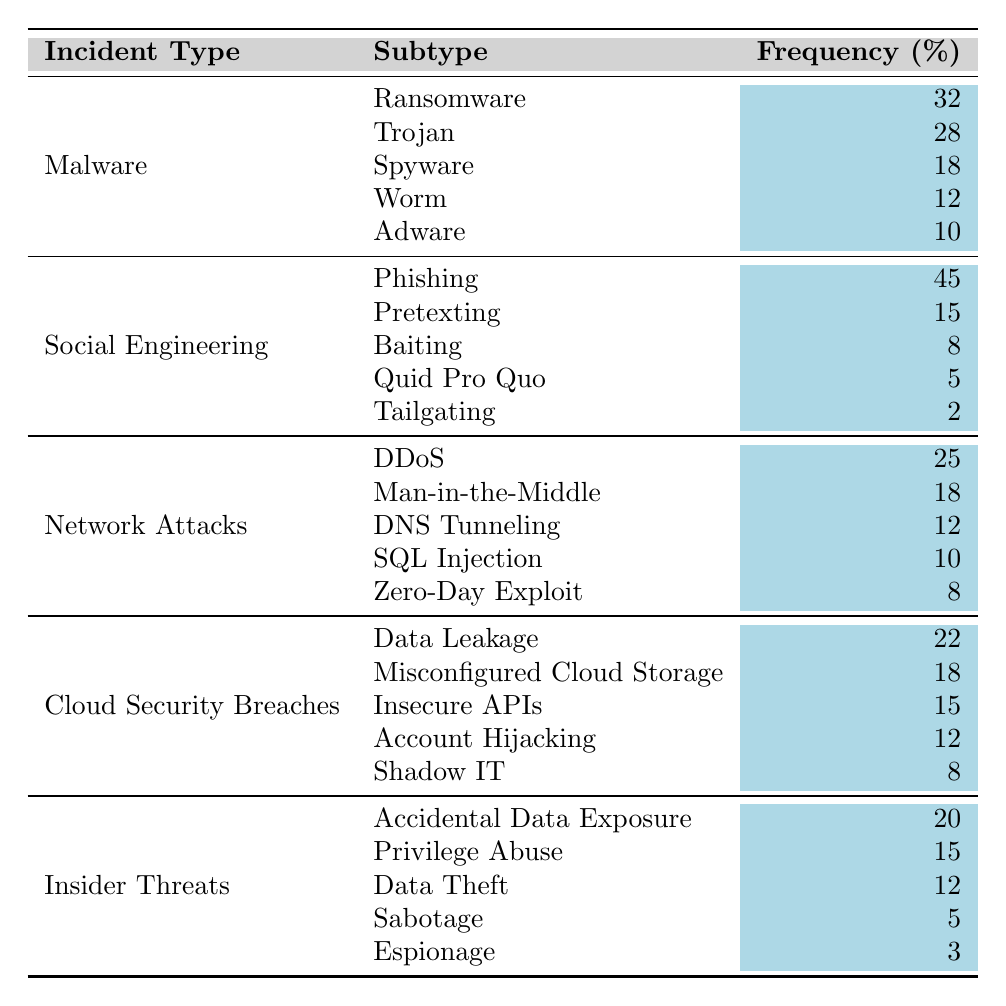What is the total frequency of Malware incidents? The table lists five types of Malware incidents: Ransomware (32), Trojan (28), Spyware (18), Worm (12), and Adware (10). To find the total frequency, we sum these values: 32 + 28 + 18 + 12 + 10 = 100.
Answer: 100 Which social engineering tactic has the highest frequency? Looking at the Social Engineering section, Phishing has the highest frequency with 45 incidents.
Answer: Phishing How many times greater is the frequency of Ransomware compared to Adware? The frequency of Ransomware is 32, and the frequency of Adware is 10. To find how many times greater Ransomware is than Adware, we divide: 32 / 10 = 3.2.
Answer: 3.2 What is the frequency of Data Leakage incidents? The table indicates that Data Leakage, a type of Cloud Security Breach, has a frequency of 22.
Answer: 22 Is the frequency of Insider Threats higher than Network Attacks? The frequency of Insider Threats (20) is lower than the frequency of Network Attacks (sum of values is 73). Therefore, the statement is false.
Answer: No What percentage of Cybersecurity incidents in 2022 were related to Malware? To find the percentage of incidents related to Malware, first calculate the total incidents across all categories: 100 (Malware) + 45 (Social Engineering) + 73 (Network Attacks) + 75 (Cloud Security Breaches) + 55 (Insider Threats) = 348. Then, the percentage is: (100 / 348) * 100 ≈ 28.74%.
Answer: Approximately 28.74% Which incident type has the lowest frequency overall? The table shows that Espionage, under Insider Threats, has the lowest frequency at 3 incidents.
Answer: Espionage What is the total frequency of Social Engineering tactics? Summing the frequencies of the Social Engineering tactics: 45 (Phishing) + 15 (Pretexting) + 8 (Baiting) + 5 (Quid Pro Quo) + 2 (Tailgating) gives us a total of 75 incidents.
Answer: 75 If we combine the frequencies of DDoS and SQL Injection, what is the result? The frequencies are 25 (DDoS) and 10 (SQL Injection). Adding these gives: 25 + 10 = 35.
Answer: 35 How does the frequency of Trojan incidents compare to that of Zero-Day Exploits? The frequency of Trojan incidents is 28, while that of Zero-Day Exploits is 8. Therefore, Trojan incidents are greater by a difference of: 28 - 8 = 20.
Answer: 20 What is the average frequency of all Malware incidents? To find the average, sum the frequencies of each category of Malware (100) and divide by the number of incident types (5): 100 / 5 = 20.
Answer: 20 